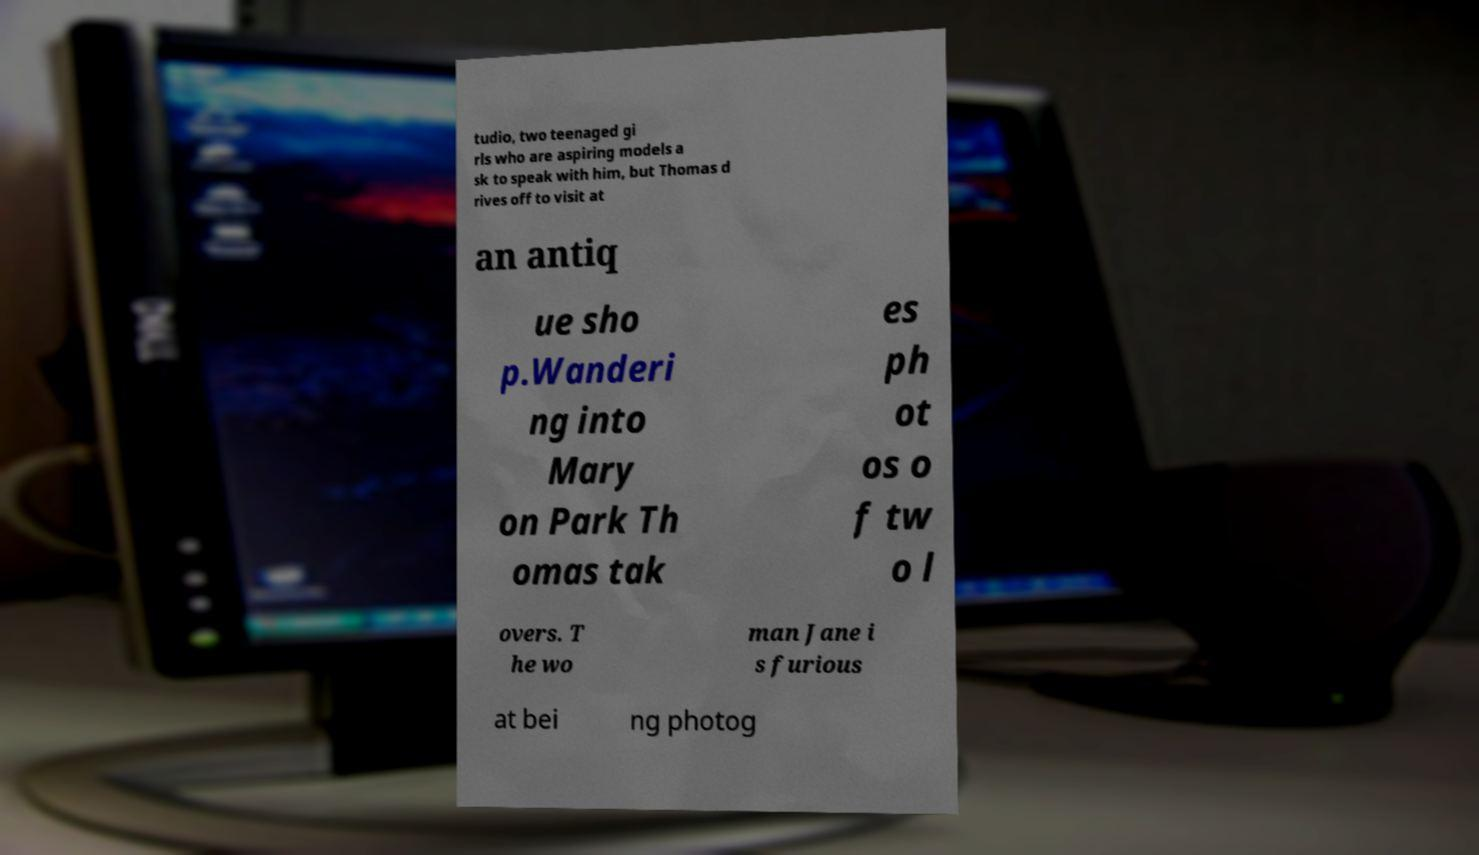For documentation purposes, I need the text within this image transcribed. Could you provide that? tudio, two teenaged gi rls who are aspiring models a sk to speak with him, but Thomas d rives off to visit at an antiq ue sho p.Wanderi ng into Mary on Park Th omas tak es ph ot os o f tw o l overs. T he wo man Jane i s furious at bei ng photog 